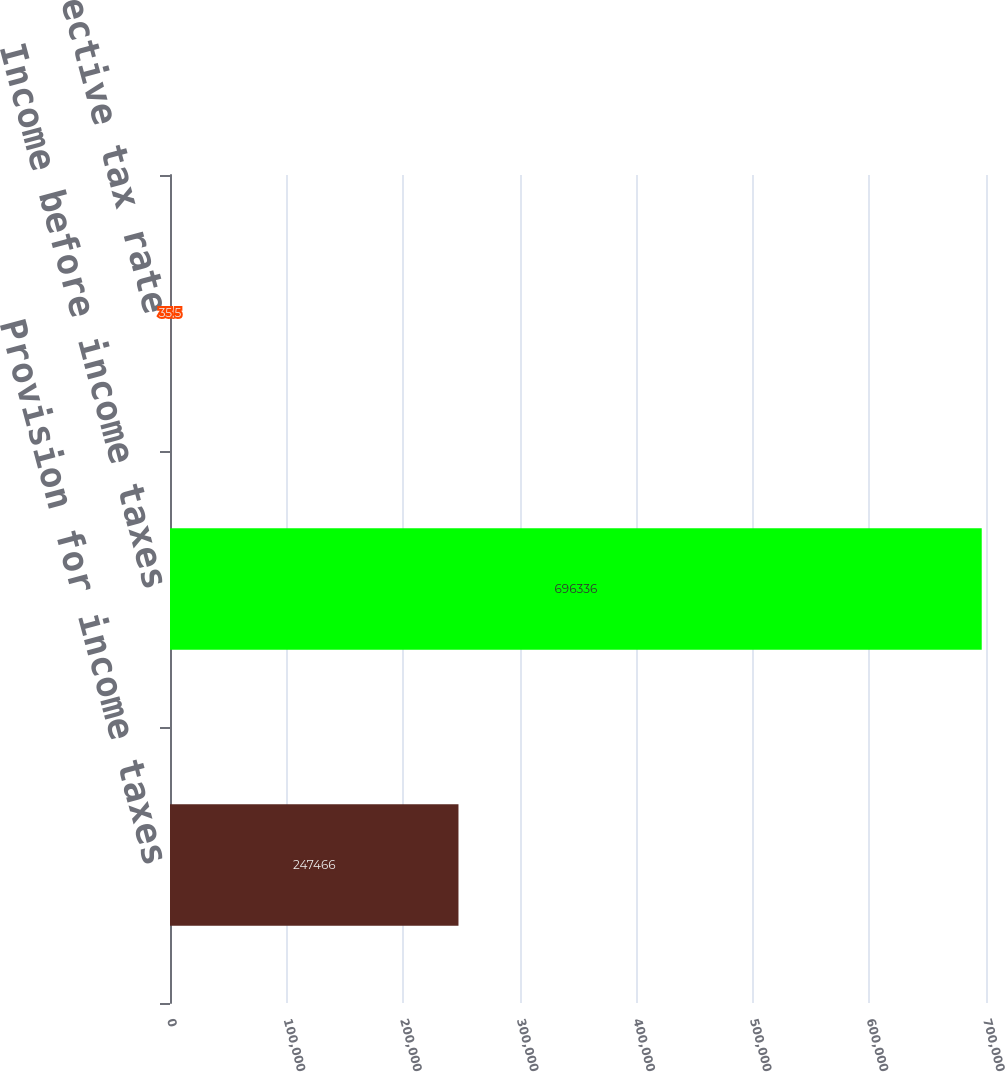Convert chart to OTSL. <chart><loc_0><loc_0><loc_500><loc_500><bar_chart><fcel>Provision for income taxes<fcel>Income before income taxes<fcel>Effective tax rate<nl><fcel>247466<fcel>696336<fcel>35.5<nl></chart> 